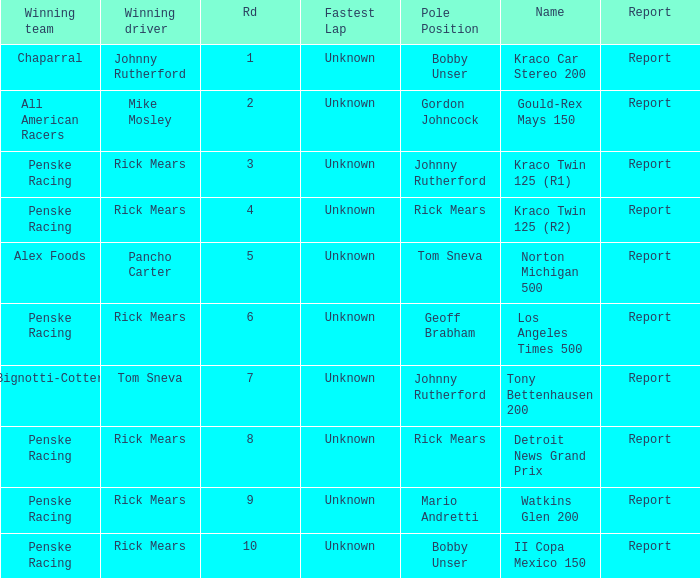The race tony bettenhausen 200 has what smallest rd? 7.0. 